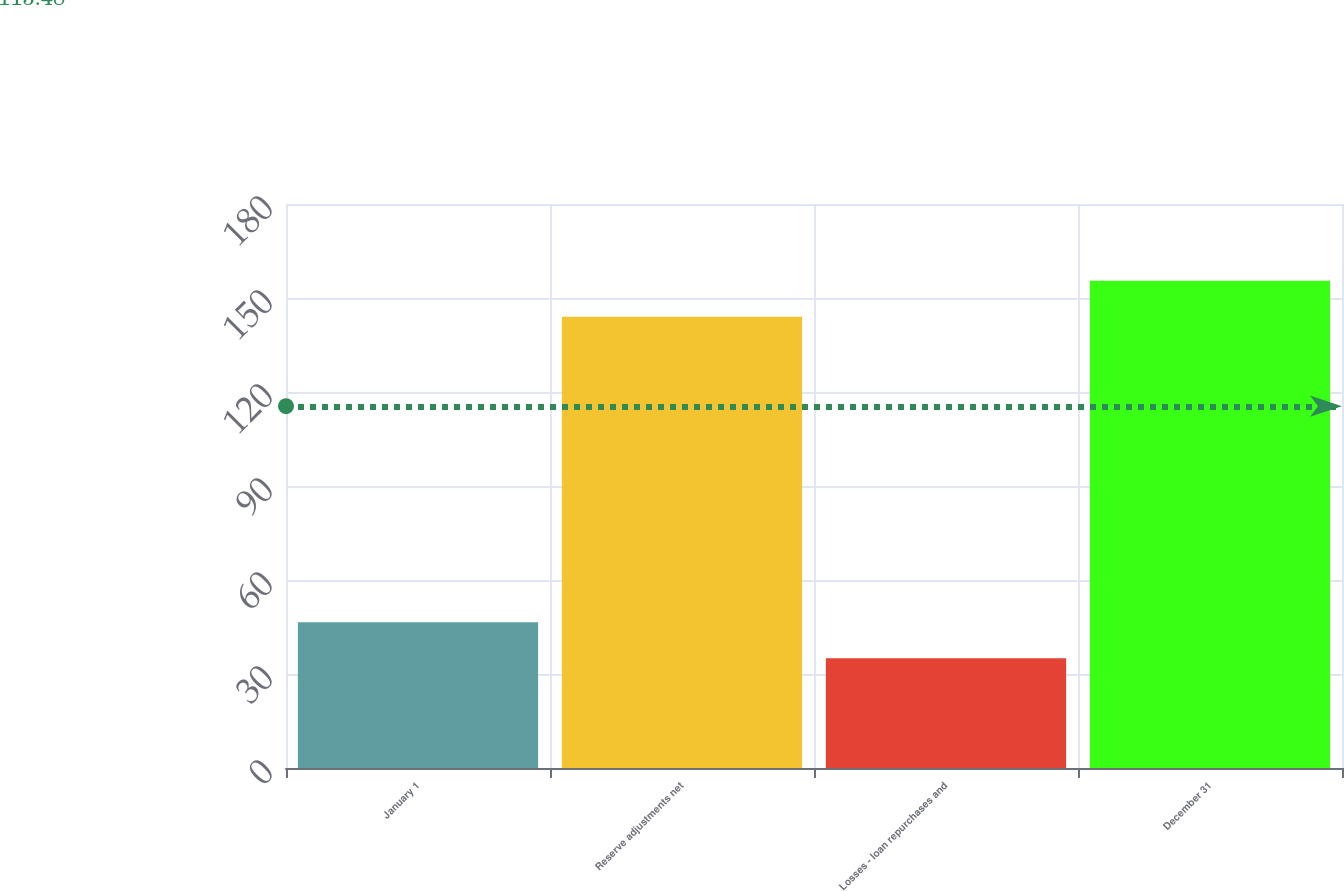Convert chart to OTSL. <chart><loc_0><loc_0><loc_500><loc_500><bar_chart><fcel>January 1<fcel>Reserve adjustments net<fcel>Losses - loan repurchases and<fcel>December 31<nl><fcel>46.5<fcel>144<fcel>35<fcel>155.5<nl></chart> 